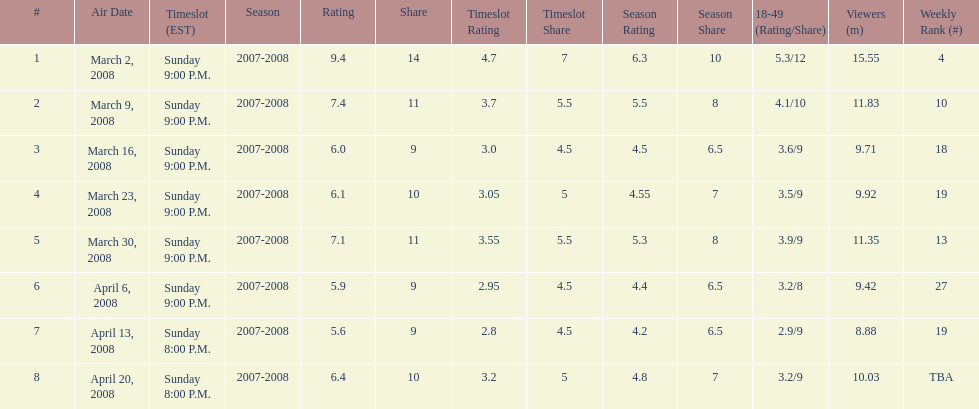Which air date had the least viewers? April 13, 2008. 